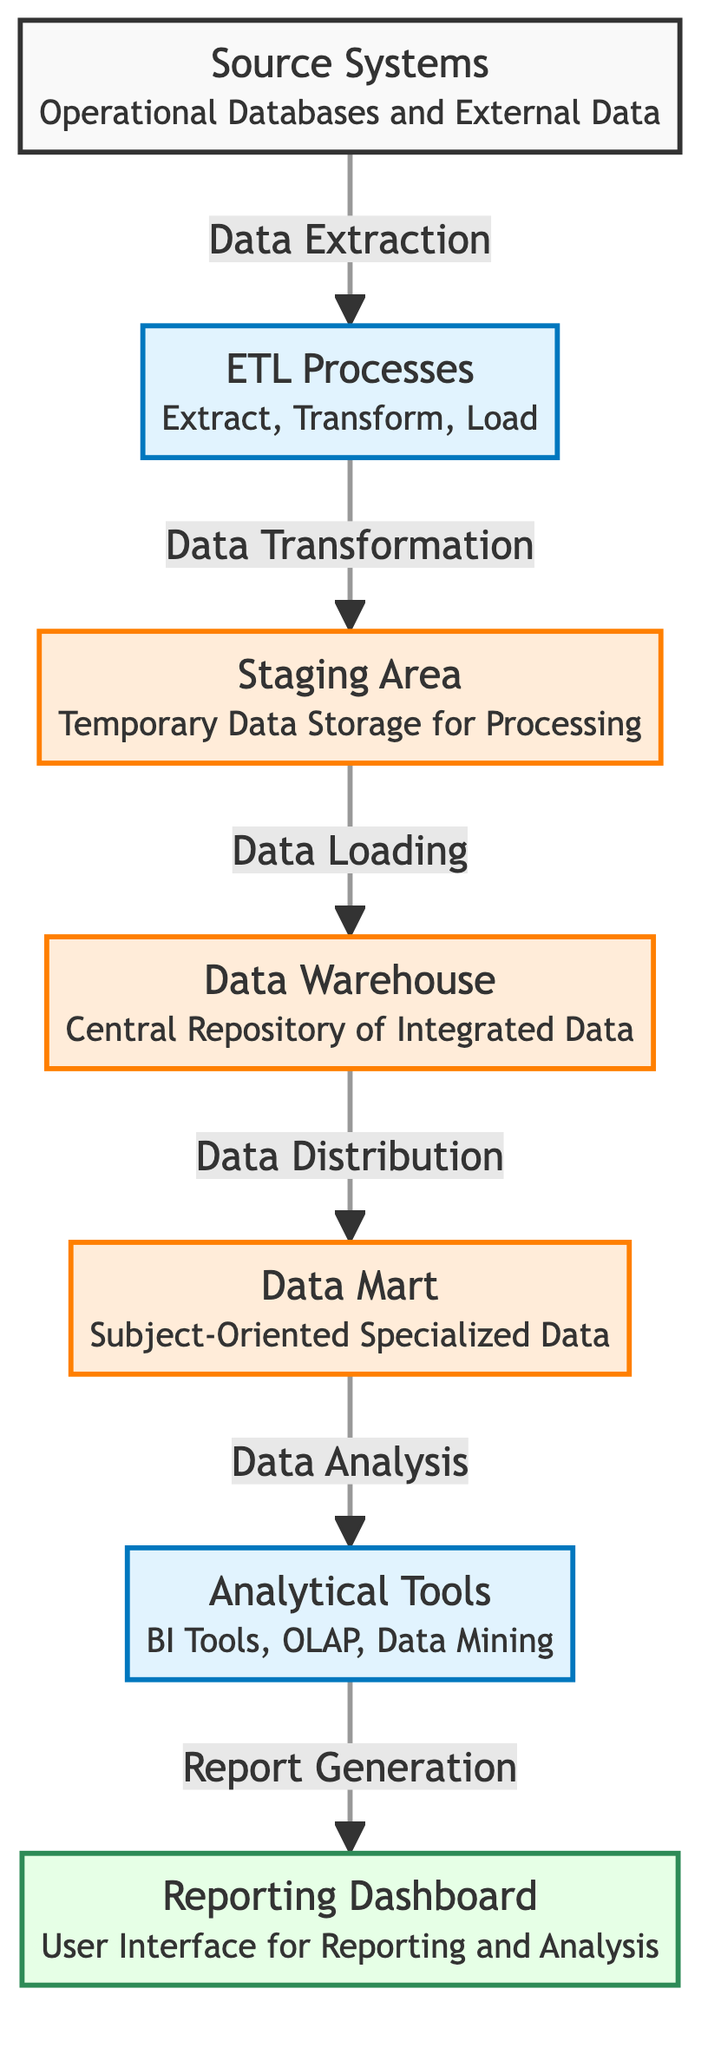What are the source systems in this diagram? The diagram identifies "Operational Databases and External Data" as the source systems, which can be found in the first node labeled "Source Systems".
Answer: Operational Databases and External Data What type of processes occur in the ETL section? The ETL section is labeled "ETL Processes" with a description mentioning "Extract, Transform, Load". This indicates the nature of processes happening there.
Answer: Extract, Transform, Load How many storage elements are depicted in this diagram? The diagram shows three storage elements: "Staging Area", "Data Warehouse", and "Data Mart". Counting these nodes gives us a total of three storage elements.
Answer: 3 Which node is connected to the reporting dashboard? Following the arrows in the diagram, the node that is connected to "Reporting Dashboard" is "Analytical Tools", indicating it directly contributes to the reporting dashboard.
Answer: Analytical Tools What is the relationship between the Data Warehouse and Data Mart? The diagram shows that the "Data Warehouse" connects to the "Data Mart" with a "Data Distribution" label, indicating that data is distributed from the warehouse to the mart.
Answer: Data Distribution Which stage follows the Staging Area in the data flow? The diagram indicates that the next stage following "Staging Area" is the "Data Warehouse", as shown by the arrow pointing from Staging Area to Data Warehouse.
Answer: Data Warehouse What is the function of Analytical Tools in this data flow? The Analytical Tools node is described as "BI Tools, OLAP, Data Mining", and it connects to the Reporting Dashboard, indicating its function is to perform analysis that generates reports.
Answer: Analysis How many data flow paths are shown in the diagram? The diagram illustrates six distinct data flow paths that connect different nodes, starting from "Source Systems" to "Reporting Dashboard".
Answer: 6 What is the purpose of the Staging Area? The Staging Area is labeled in the diagram as "Temporary Data Storage for Processing", which defines its role within the overall data flow.
Answer: Temporary Data Storage for Processing 